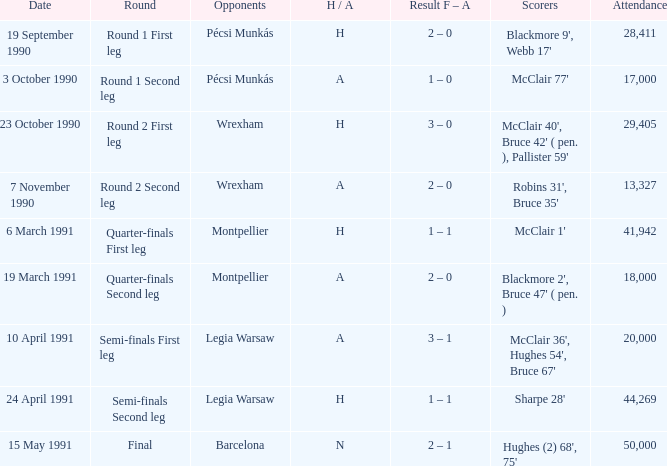What is the lowest attendance when the h/A is H in the Semi-Finals Second Leg? 44269.0. 